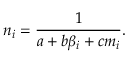Convert formula to latex. <formula><loc_0><loc_0><loc_500><loc_500>n _ { i } = \frac { 1 } { a + b \beta _ { i } + c m _ { i } } .</formula> 